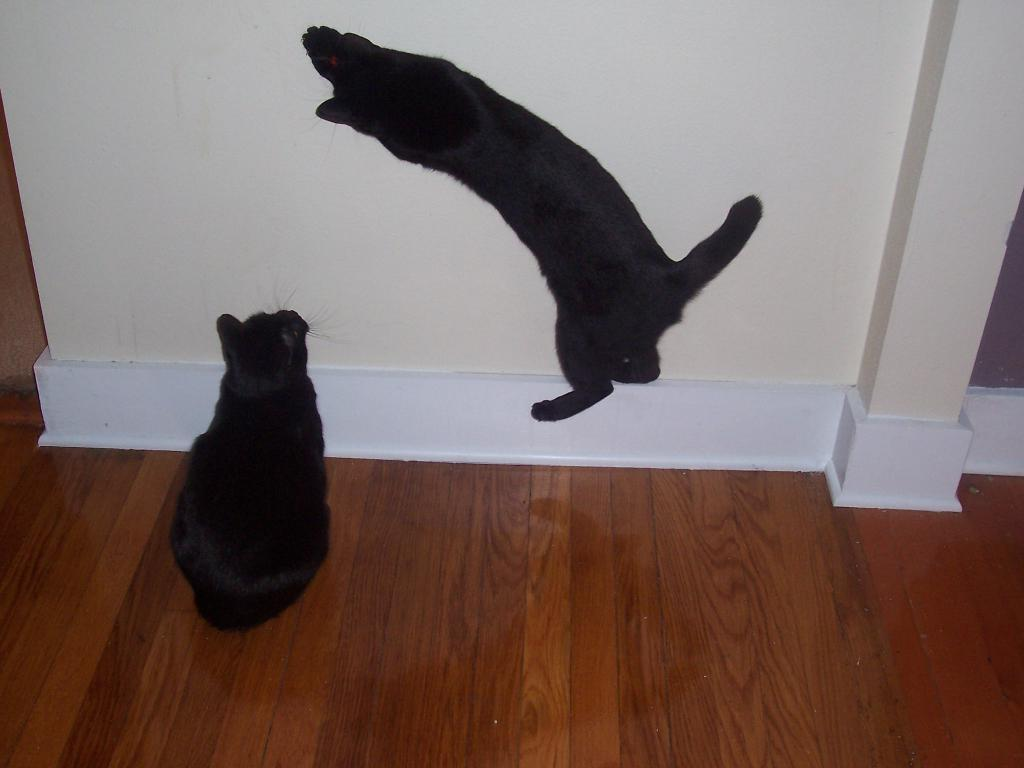What type of animals are in the image? There are cats in the image. What can be seen in the background of the image? There is a wall in the background of the image. What is at the bottom of the image? There is a floor at the bottom of the image. What type of brick is being exchanged between the cats in the image? There is no brick or exchange of any kind depicted in the image; it features cats and a wall in the background. 